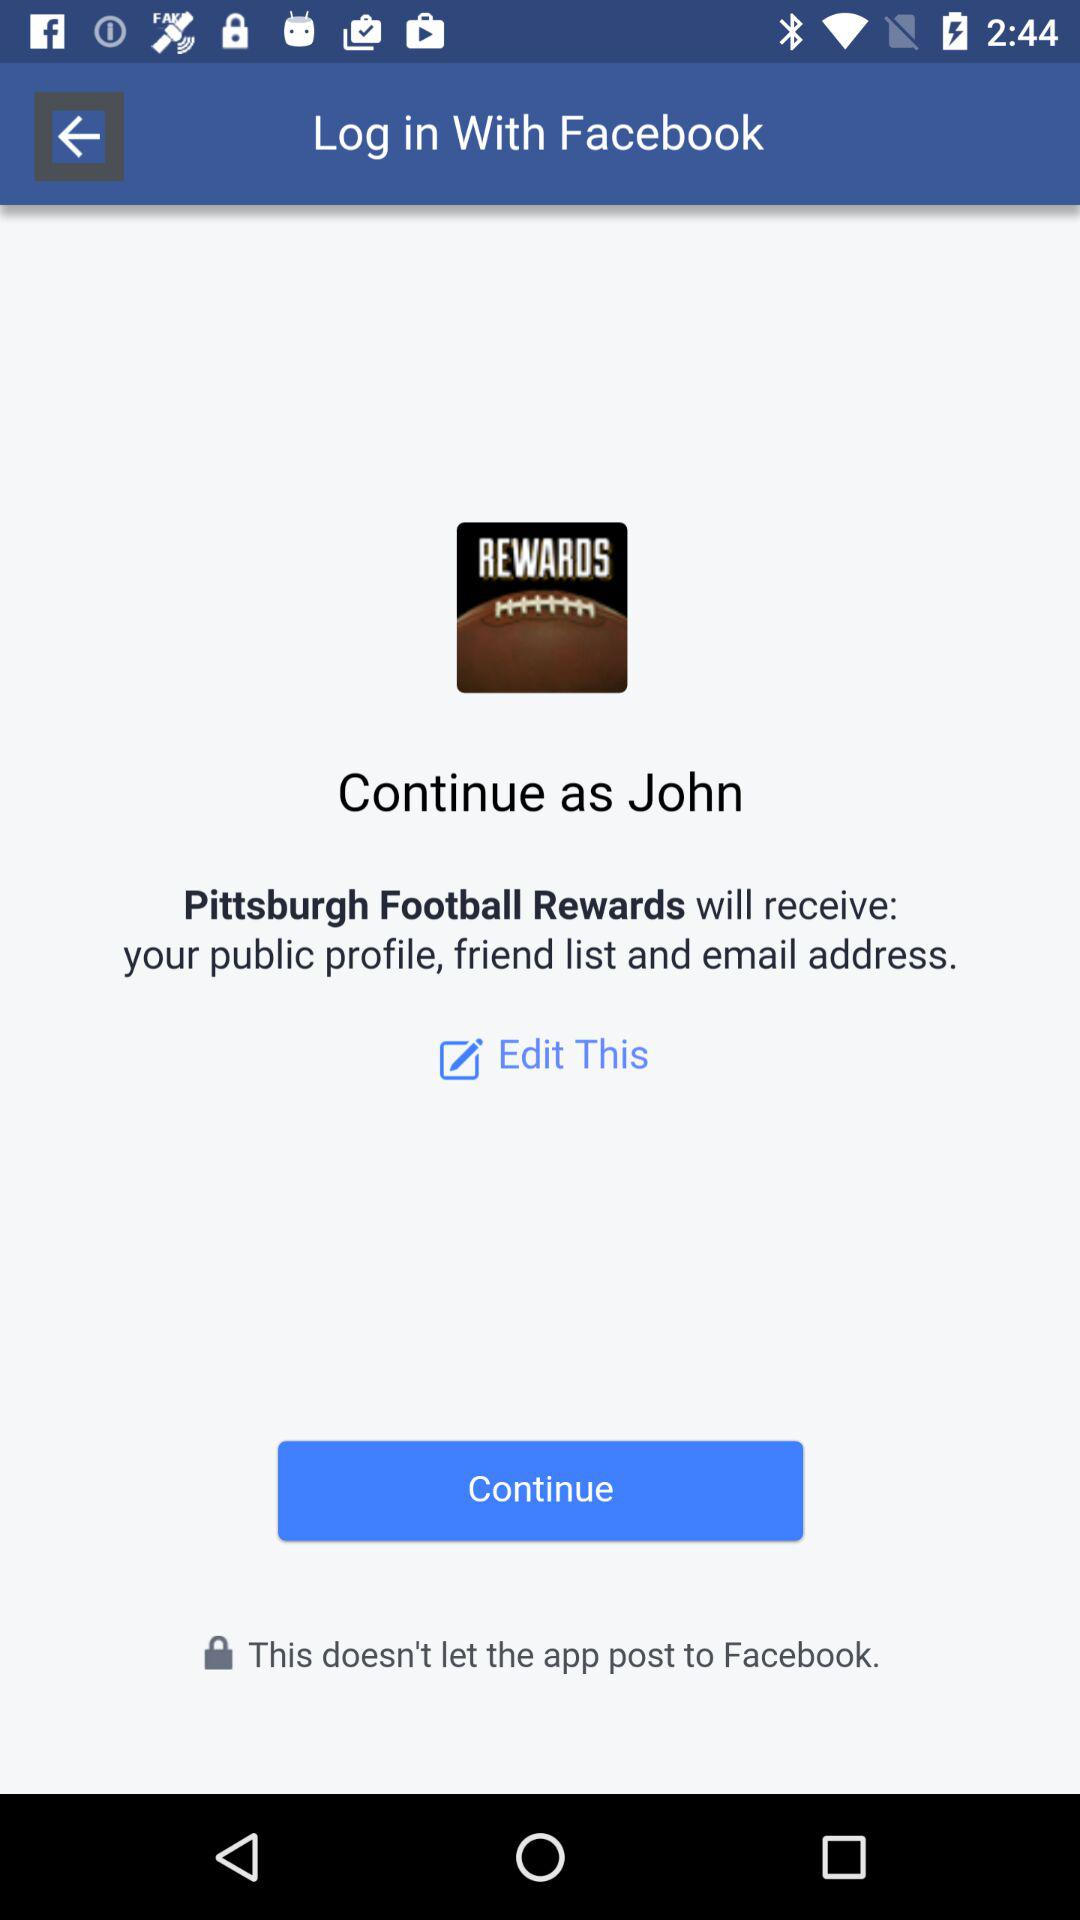Who will receive the public profile, friend list and email address? The public profile, friend list and email address will be received by "Pittsburgh Football Rewards". 